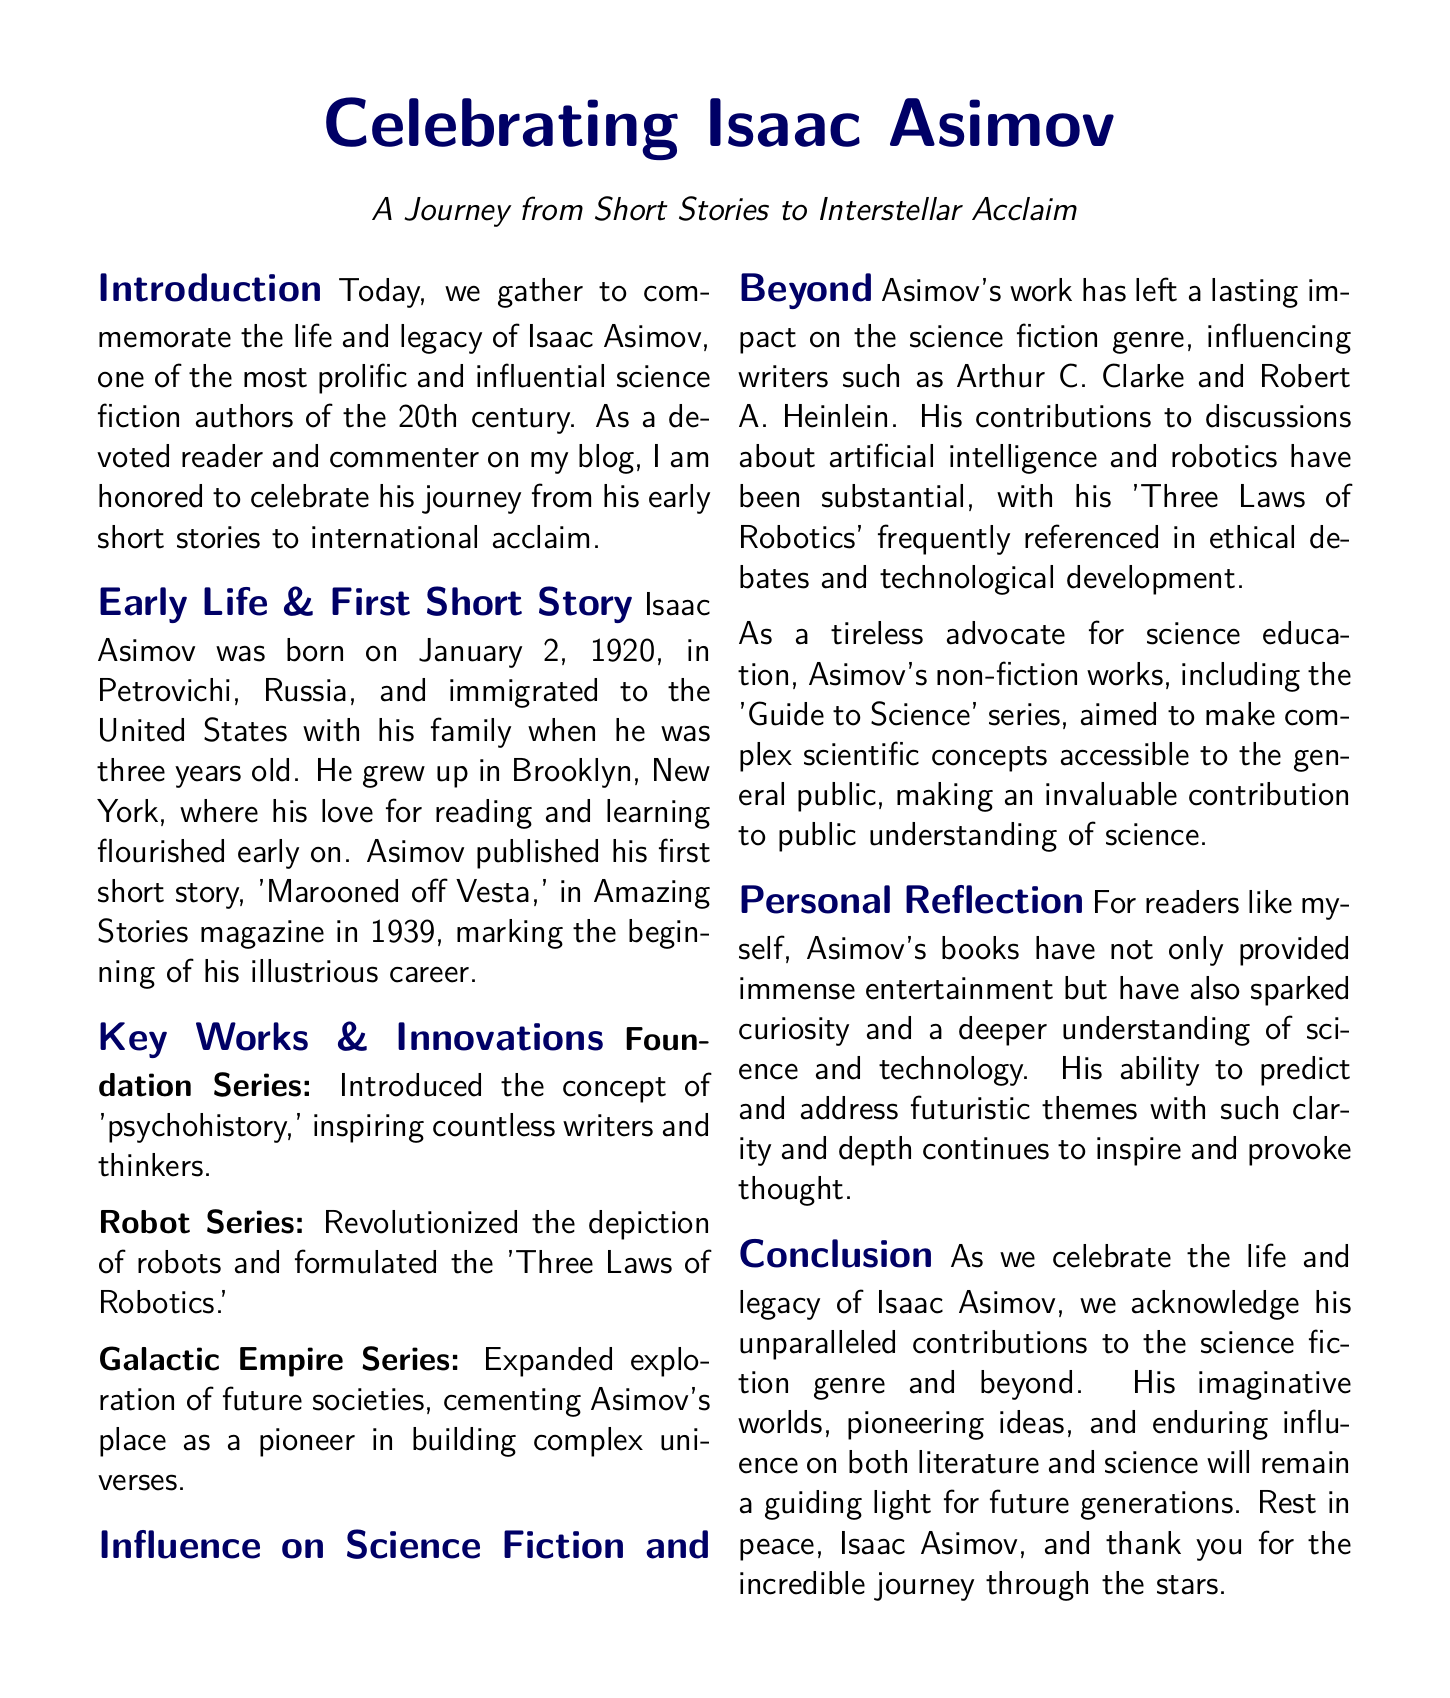What was Isaac Asimov's first published short story? The document states that his first short story was published in Amazing Stories magazine, specifically titled 'Marooned off Vesta.'
Answer: 'Marooned off Vesta' When was Isaac Asimov born? The document provides the birth date of Isaac Asimov, which is January 2, 1920.
Answer: January 2, 1920 What series introduced the concept of 'psychohistory'? The document mentions the Foundation Series as the work that introduced this concept.
Answer: Foundation Series What are the 'Three Laws of Robotics'? The document refers to the Robot Series as having formulated the 'Three Laws of Robotics,' but does not explicitly list them.
Answer: Robot Series Which famous science fiction authors were influenced by Asimov? The document names Arthur C. Clarke and Robert A. Heinlein as authors influenced by Asimov's work.
Answer: Arthur C. Clarke and Robert A. Heinlein What aspect of science did Asimov aim to make accessible to the general public? The document highlights that Asimov's non-fiction works aimed to make complex scientific concepts accessible.
Answer: Complex scientific concepts What did Asimov contribute to discussions beyond science fiction? The document notes that his work contributed to discussions about artificial intelligence and robotics.
Answer: Artificial intelligence and robotics How does the document describe personal reflections on Asimov's work? It states that Asimov's books have sparked curiosity and a deeper understanding of science and technology for readers.
Answer: Sparked curiosity and deeper understanding What is emphasized at the conclusion of the document? The conclusion emphasizes acknowledging Asimov's contributions to the science fiction genre and his enduring influence.
Answer: Acknowledging contributions and enduring influence 